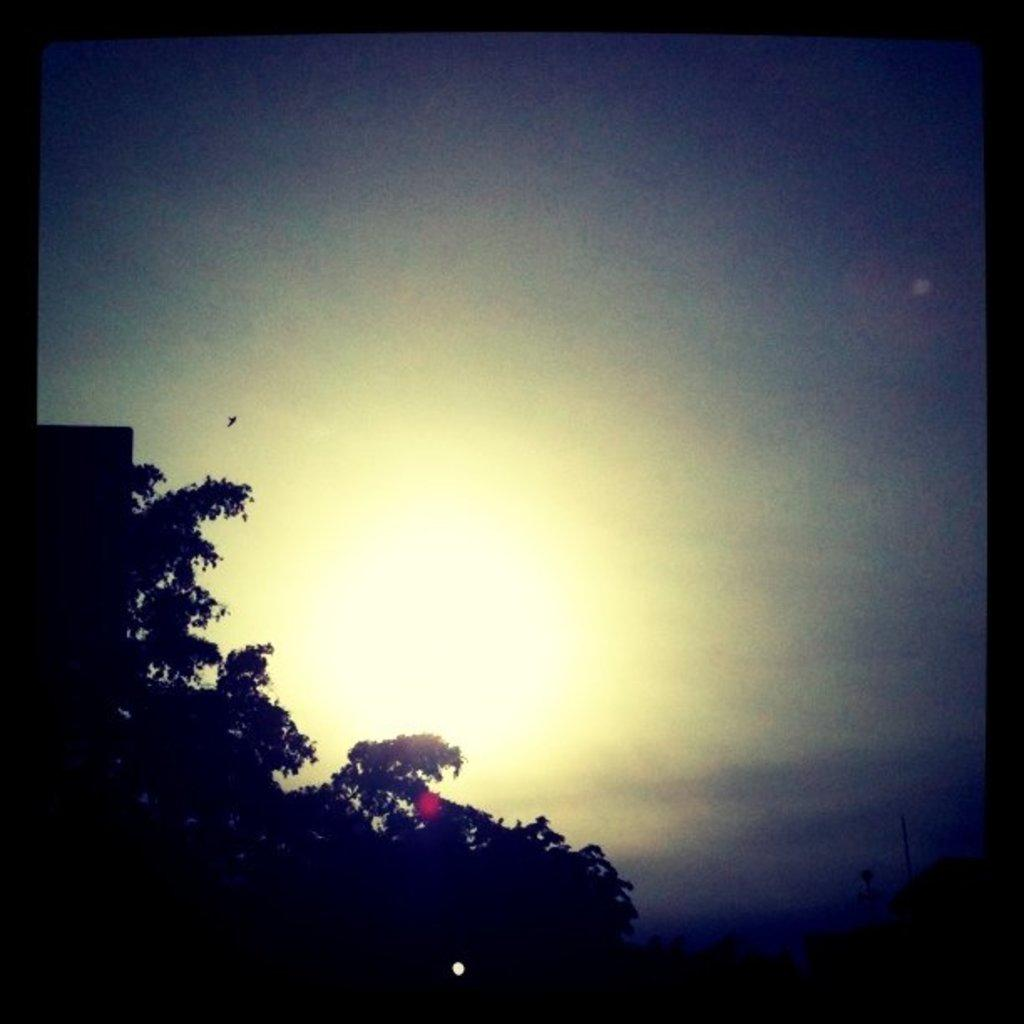What type of vegetation is on the left side of the image? There are trees on the left side of the image. What is visible above the trees in the image? The sky is visible above the trees in the image. What type of chalk is being used to draw on the trees in the image? There is no chalk or drawing present on the trees in the image. Can you provide an example of a trick that can be performed using the trees in the image? There is no trick or performance depicted in the image; it simply shows trees and the sky above them. 